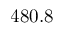<formula> <loc_0><loc_0><loc_500><loc_500>4 8 0 . 8</formula> 